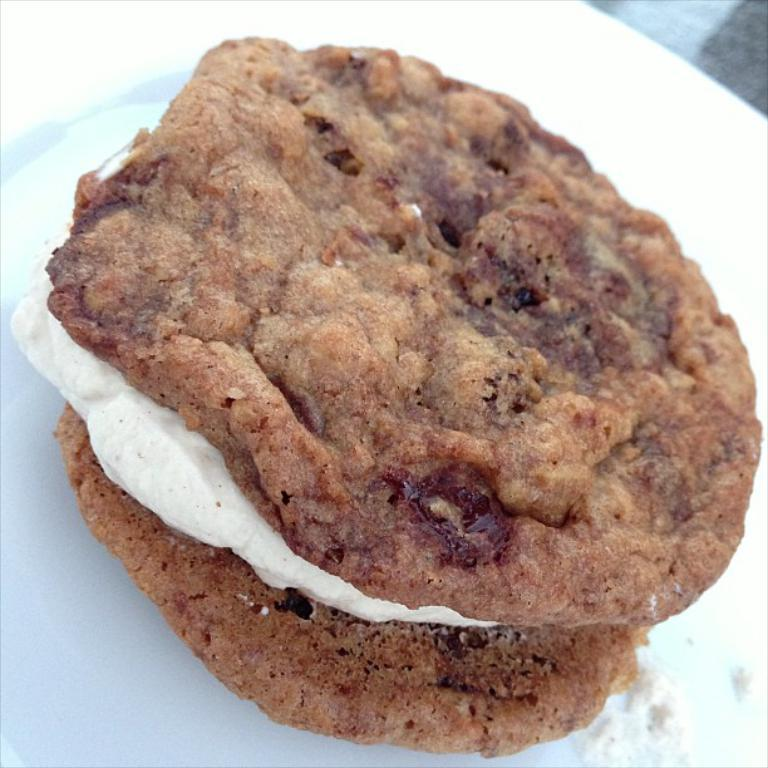What is on the plate in the image? There is food on the plate in the image. Can you describe the appearance of the food? The food is brown and white in color. What color is the plate in the image? The plate in the image is white. What type of watch can be seen on the plate in the image? There is no watch present on the plate in the image; it contains food. 